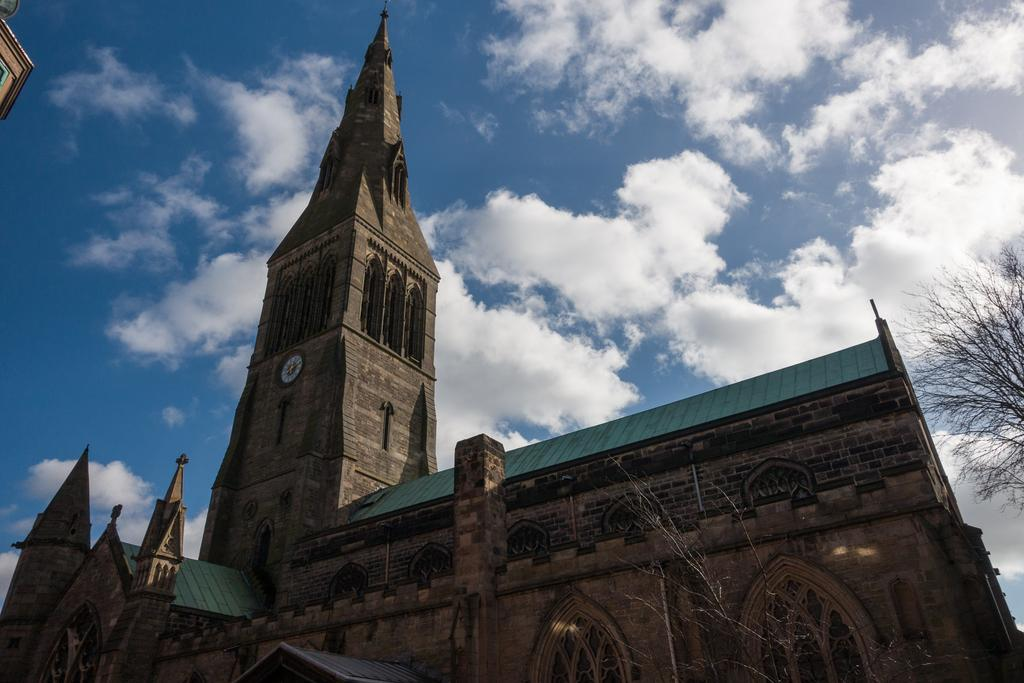What type of building is in the image? There is a clock tower building in the image. What other elements can be seen in the image? There are trees in the image. How would you describe the sky in the image? The sky is cloudy in the image. What type of haircut is the clock tower building getting in the image? The clock tower building is not getting a haircut in the image, as it is a building and not a person. 